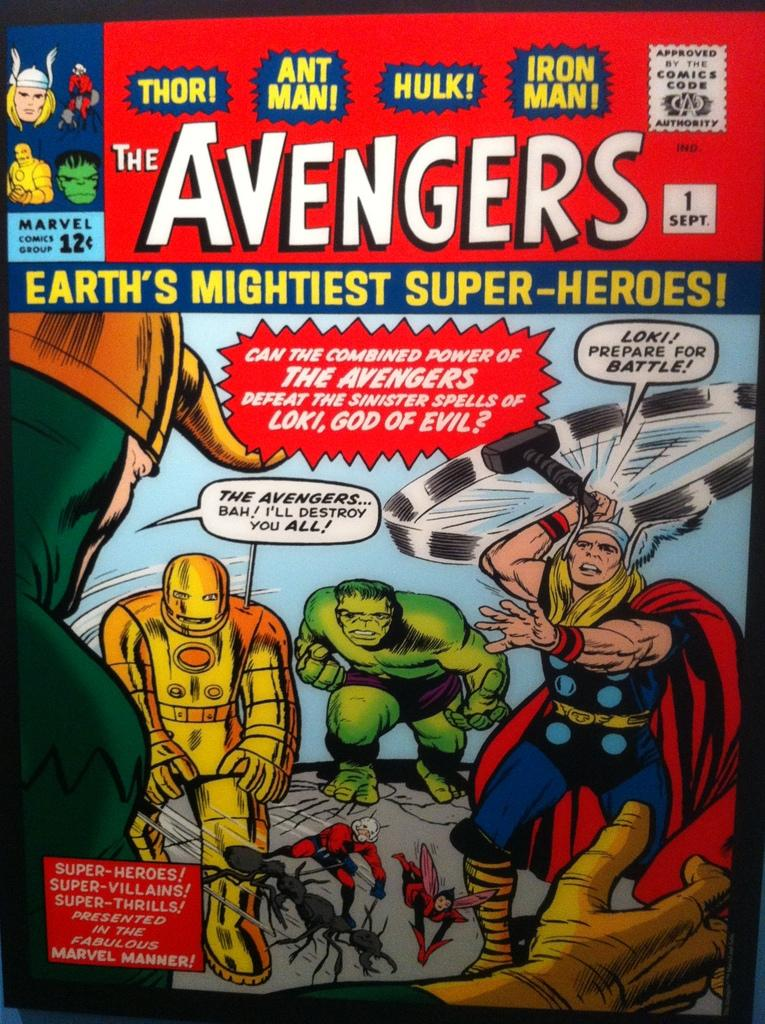<image>
Provide a brief description of the given image. A comic book titled "The Avengers" earth's mightiest super-heroes. 